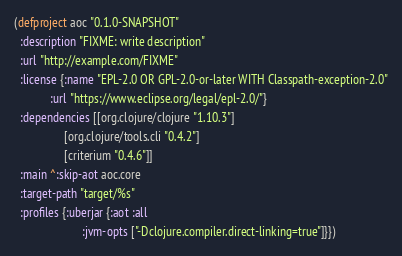Convert code to text. <code><loc_0><loc_0><loc_500><loc_500><_Clojure_>(defproject aoc "0.1.0-SNAPSHOT"
  :description "FIXME: write description"
  :url "http://example.com/FIXME"
  :license {:name "EPL-2.0 OR GPL-2.0-or-later WITH Classpath-exception-2.0"
            :url "https://www.eclipse.org/legal/epl-2.0/"}
  :dependencies [[org.clojure/clojure "1.10.3"]
                 [org.clojure/tools.cli "0.4.2"]
                 [criterium "0.4.6"]]
  :main ^:skip-aot aoc.core
  :target-path "target/%s"
  :profiles {:uberjar {:aot :all
                       :jvm-opts ["-Dclojure.compiler.direct-linking=true"]}})
</code> 